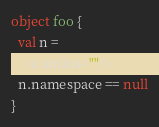Convert code to text. <code><loc_0><loc_0><loc_500><loc_500><_Scala_>object foo {
  val n = 
    <a xmlns=""/>
  n.namespace == null
}
</code> 